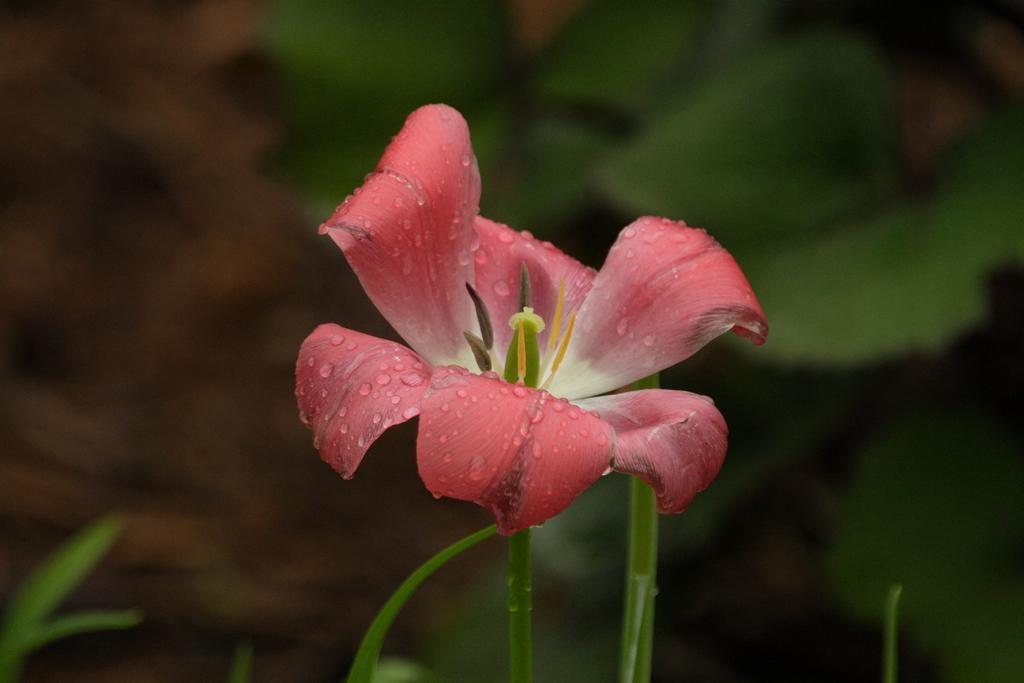Could you give a brief overview of what you see in this image? In this picture we can see a flower and in the background we can see plants and it is blurry. 